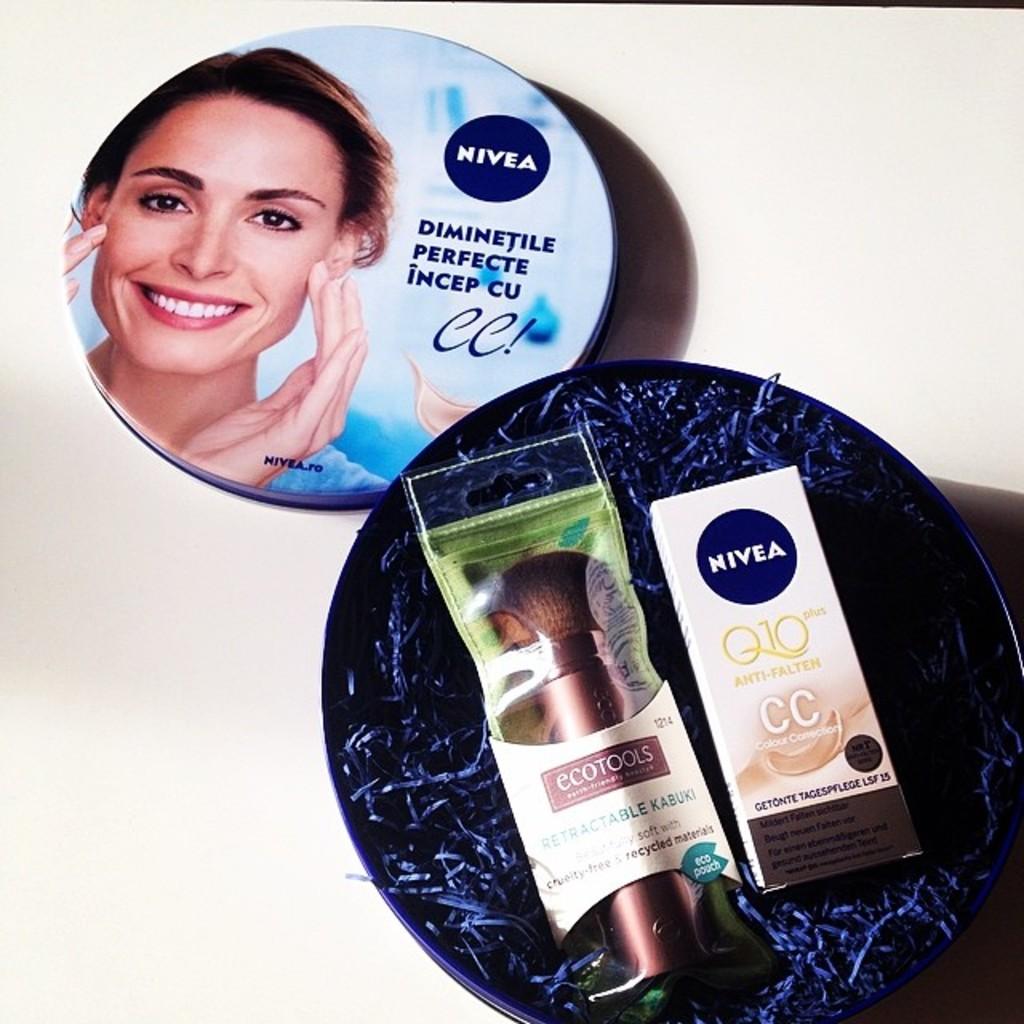Isthe bottle empty?
Give a very brief answer. Unanswerable. 